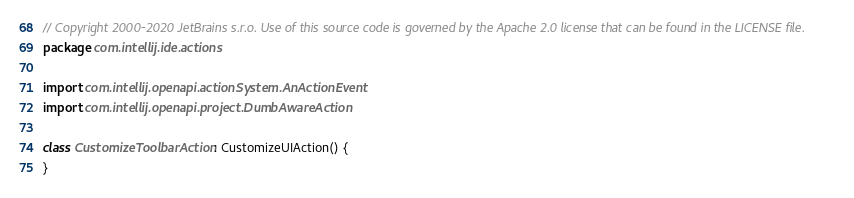<code> <loc_0><loc_0><loc_500><loc_500><_Kotlin_>// Copyright 2000-2020 JetBrains s.r.o. Use of this source code is governed by the Apache 2.0 license that can be found in the LICENSE file.
package com.intellij.ide.actions

import com.intellij.openapi.actionSystem.AnActionEvent
import com.intellij.openapi.project.DumbAwareAction

class CustomizeToolbarAction: CustomizeUIAction() {
}</code> 